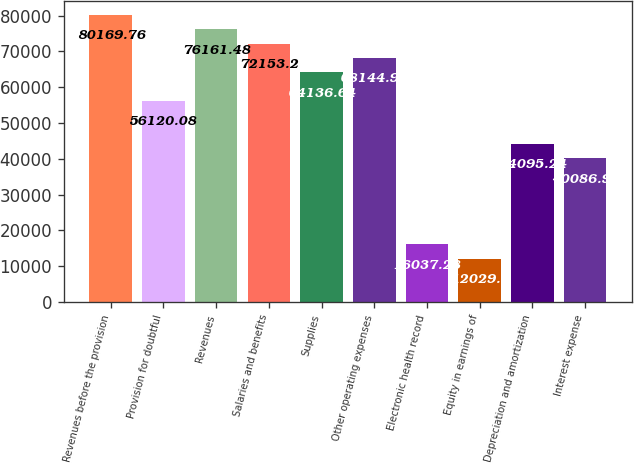Convert chart. <chart><loc_0><loc_0><loc_500><loc_500><bar_chart><fcel>Revenues before the provision<fcel>Provision for doubtful<fcel>Revenues<fcel>Salaries and benefits<fcel>Supplies<fcel>Other operating expenses<fcel>Electronic health record<fcel>Equity in earnings of<fcel>Depreciation and amortization<fcel>Interest expense<nl><fcel>80169.8<fcel>56120.1<fcel>76161.5<fcel>72153.2<fcel>64136.6<fcel>68144.9<fcel>16037.3<fcel>12029<fcel>44095.2<fcel>40087<nl></chart> 